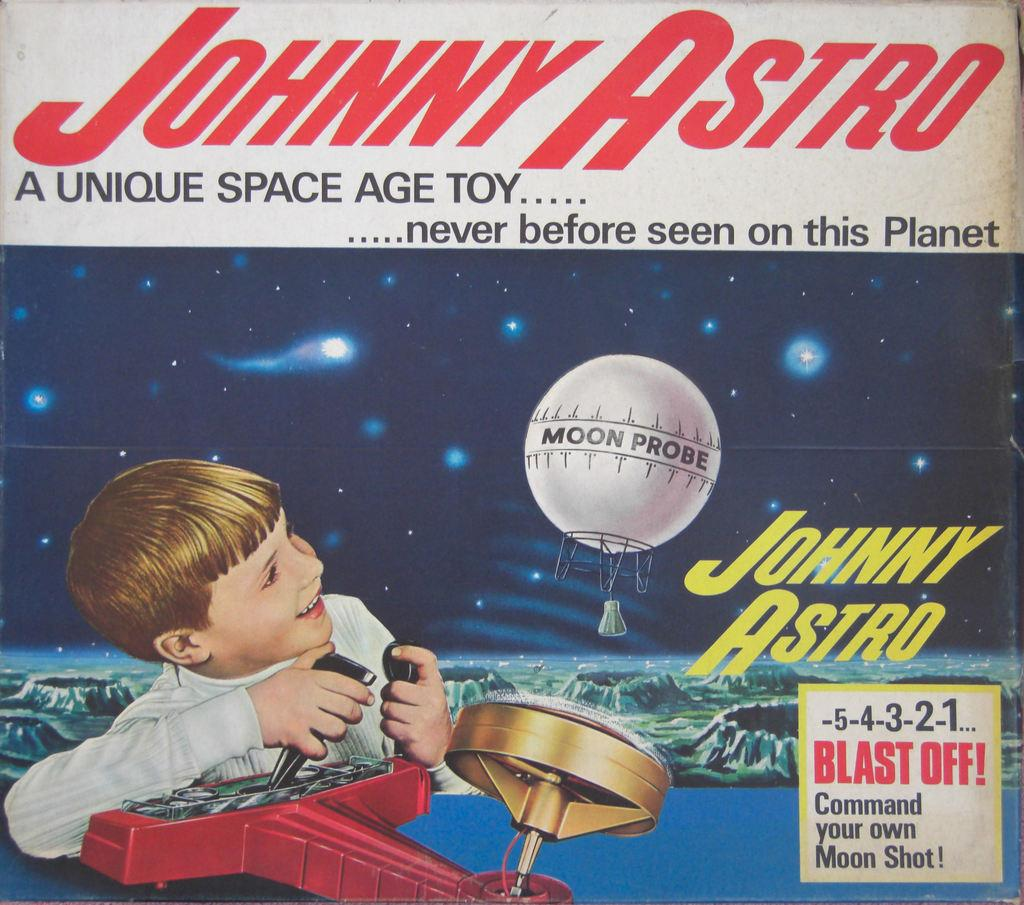What type of visual is the image? The image is a poster. What is the main subject of the poster? There is a kid depicted in the poster. What else can be found in the poster besides the kid? There is text present in the poster and objects visible in the poster. What kind of celestial bodies are present in the poster? Stars are present in the poster. What type of pickle is being used as a prop in the poster? There is no pickle present in the poster. Can you describe the hose that is being used by the kid in the poster? There is no hose depicted in the poster; the kid is not using any such object. 